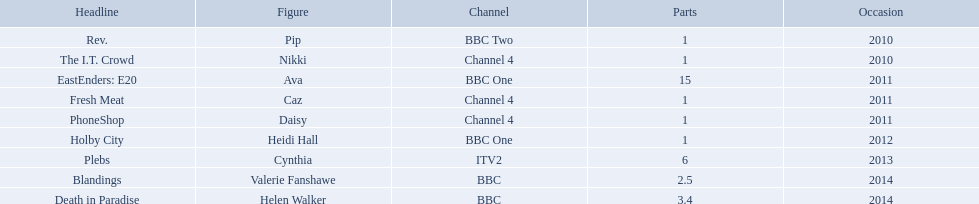What is the total number of shows sophie colguhoun appeared in? 9. 